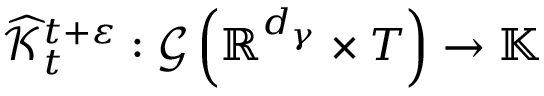Convert formula to latex. <formula><loc_0><loc_0><loc_500><loc_500>\widehat { \mathcal { K } } _ { t } ^ { t + \varepsilon } \colon \mathcal { G } \left ( \mathbb { R } ^ { d _ { \gamma } } \times T \right ) \rightarrow \mathbb { K }</formula> 